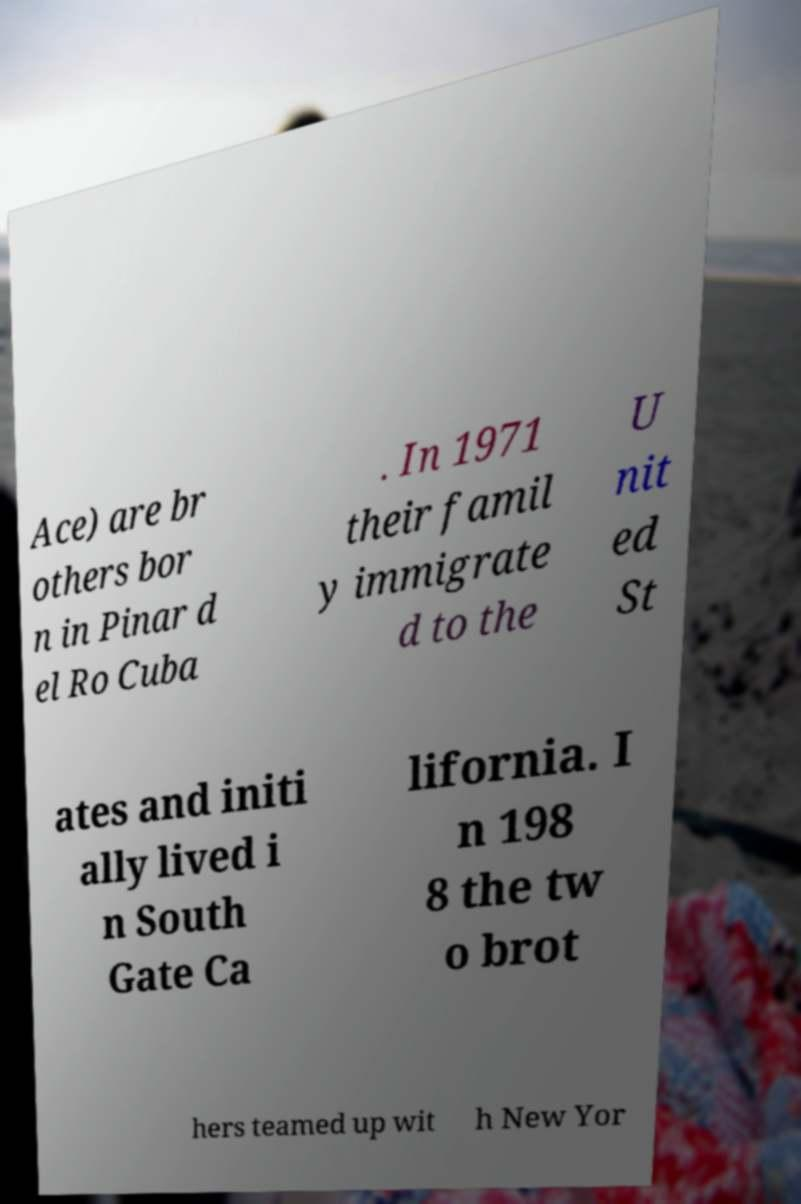Could you extract and type out the text from this image? Ace) are br others bor n in Pinar d el Ro Cuba . In 1971 their famil y immigrate d to the U nit ed St ates and initi ally lived i n South Gate Ca lifornia. I n 198 8 the tw o brot hers teamed up wit h New Yor 